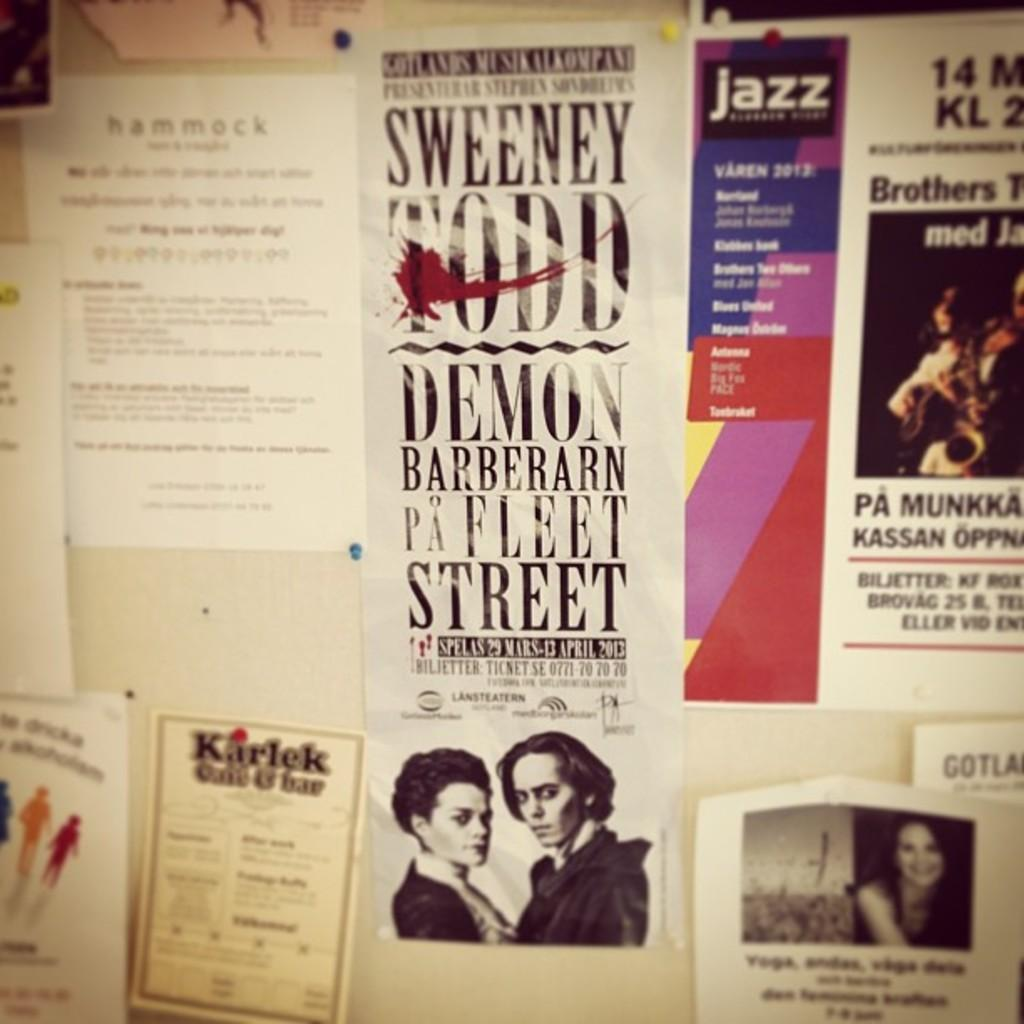<image>
Write a terse but informative summary of the picture. A wall of advertisements including Sweeney Todd and a Jazz festival. 